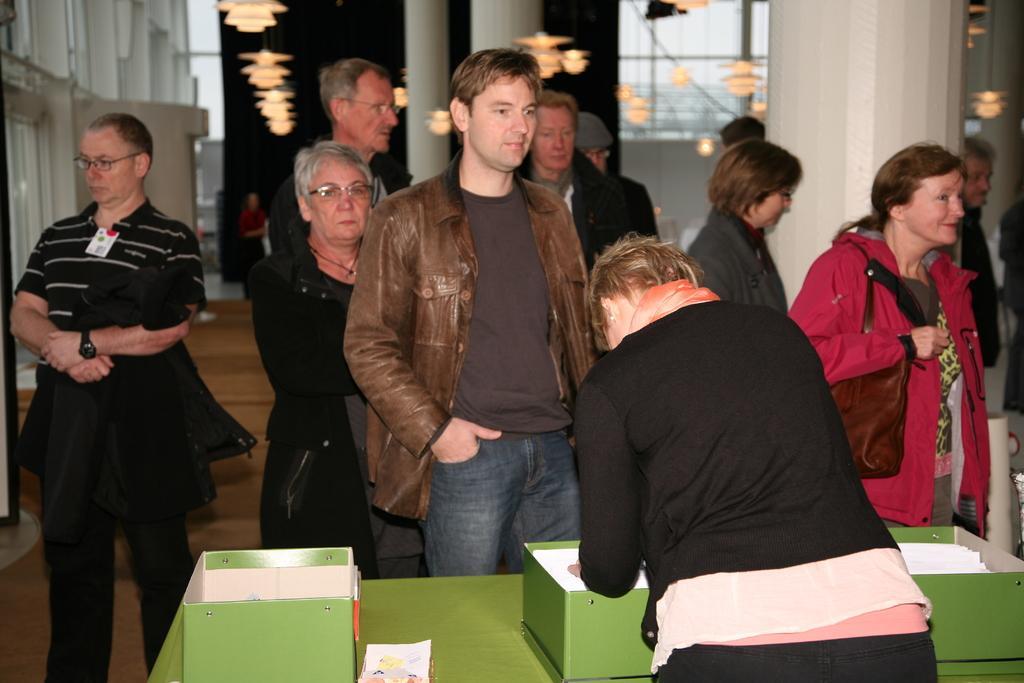How would you summarize this image in a sentence or two? In this image, we can see people wearing clothes. There is a table at the bottom of the image contains boxes. There is a pillar in the top right of the image. There are lights at the top of the image. 